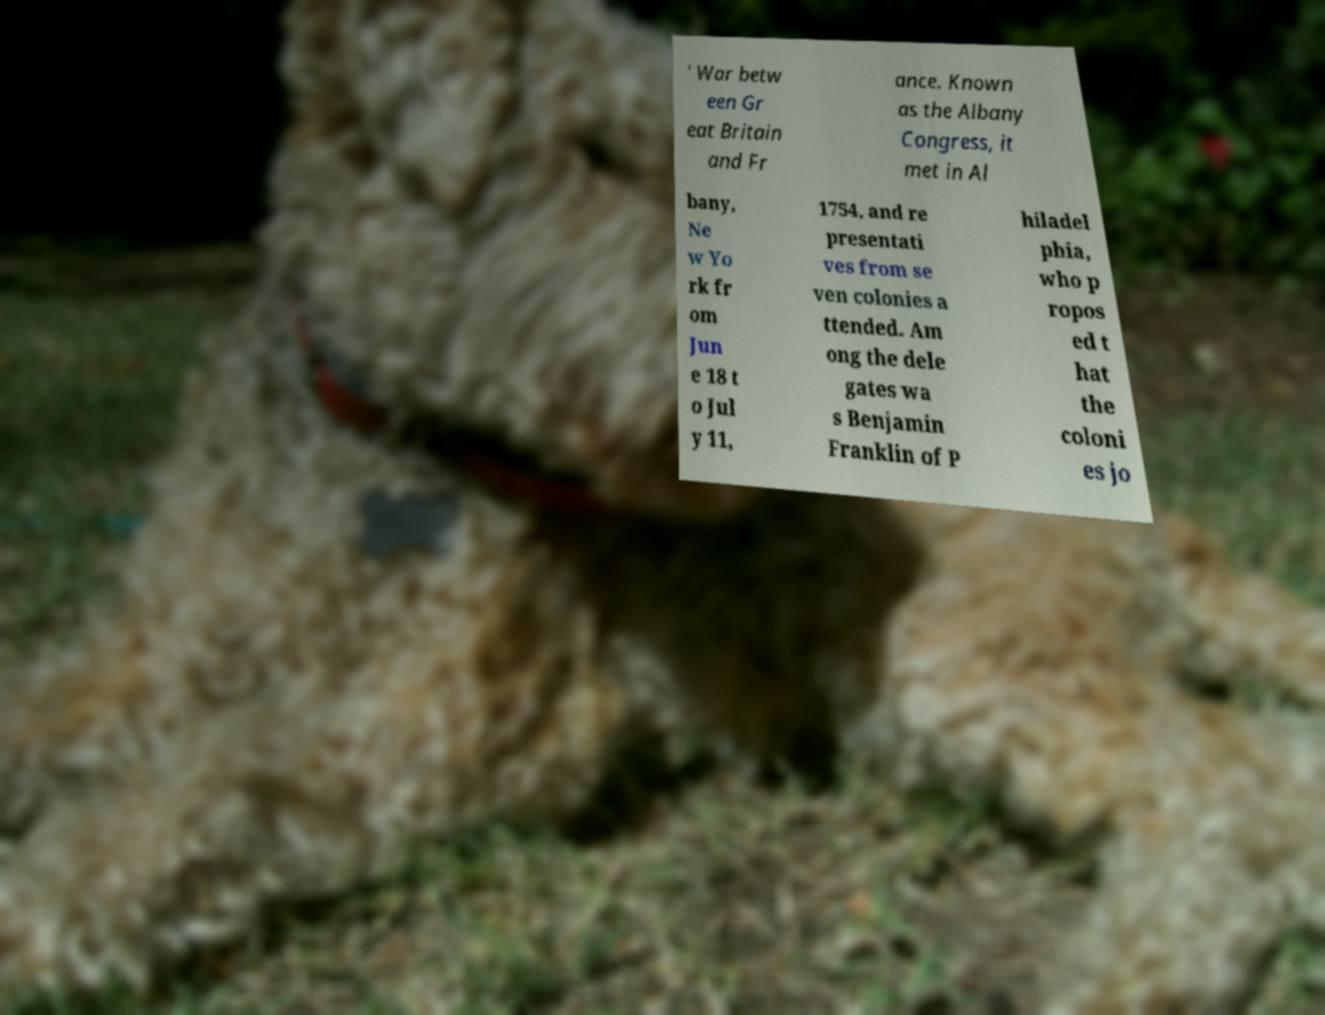What messages or text are displayed in this image? I need them in a readable, typed format. ' War betw een Gr eat Britain and Fr ance. Known as the Albany Congress, it met in Al bany, Ne w Yo rk fr om Jun e 18 t o Jul y 11, 1754, and re presentati ves from se ven colonies a ttended. Am ong the dele gates wa s Benjamin Franklin of P hiladel phia, who p ropos ed t hat the coloni es jo 